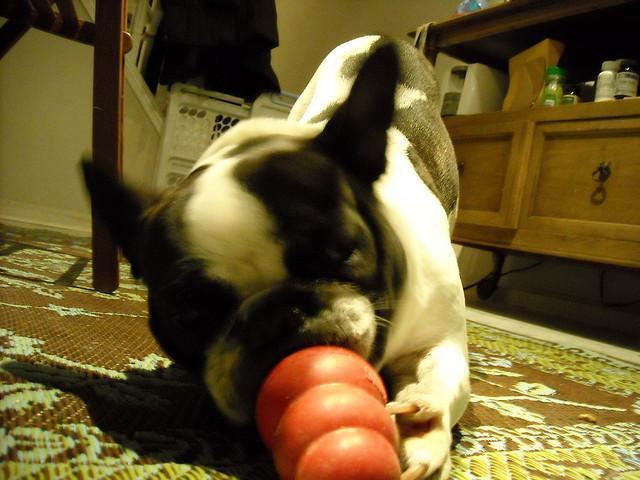How many sports balls are visible?
Give a very brief answer. 3. 